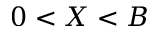<formula> <loc_0><loc_0><loc_500><loc_500>0 < X < B</formula> 